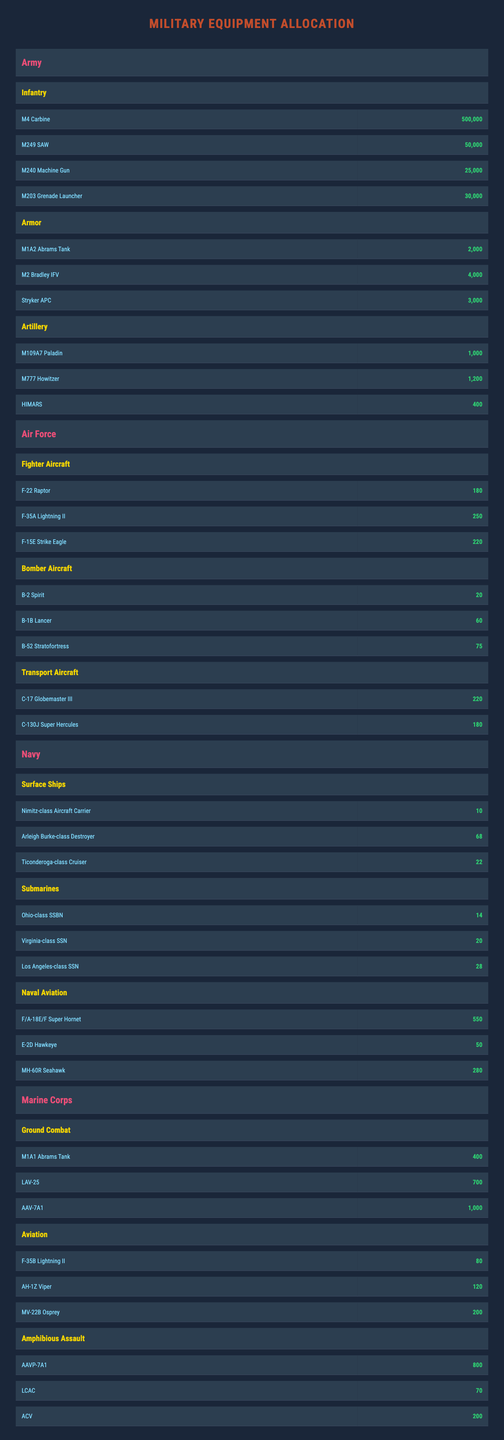What is the total number of M4 Carbines allocated to the Army? The value for M4 Carbine under the Army's Infantry division is 500,000, so the total allocated is simply that value.
Answer: 500,000 Which branch has the highest number of transport aircraft? Under the Air Force, the transport aircraft total up to C-17 (220) and C-130J (180), giving a total of 400. No other branch has transport aircraft listed in the table.
Answer: Air Force How many more F-35A Lightning IIs does the Air Force have compared to the Marine Corps' F-35B Lightning IIs? The Air Force has 250 F-35A Lightning IIs, while the Marine Corps has 80 F-35B Lightning IIs. To find the difference, we subtract 80 from 250, resulting in 170 more.
Answer: 170 What is the combined number of naval surface ships listed? The Navy has 10 Nimitz-class Aircraft Carriers, 68 Arleigh Burke-class Destroyers, and 22 Ticonderoga-class Cruisers. Adding these gives 10 + 68 + 22 = 100 surface ships in total.
Answer: 100 Which branch of the military has the least amount of equipment overall? To answer this, one must sum the total equipment counts of each branch. The Army has 577,000, the Air Force has 425, the Navy has 110, and the Marine Corps has 2,060. The Navy has 110, making it the branch with the least amount of equipment based on total counts.
Answer: Navy Is the number of M1A2 Abrams Tanks greater than that of M1A1 Abrams Tanks? The Army has 2,000 M1A2 Abrams Tanks, and the Marine Corps has 400 M1A1 Abrams Tanks. Since 2,000 is greater than 400, the statement is true.
Answer: Yes What is the average number of artillery pieces across the Army's Artillery division? The Army has three types of artillery: M109A7 Paladin (1,000), M777 Howitzer (1,200), and HIMARS (400). The total is 1,000 + 1,200 + 400 = 2,600. Dividing by 3 shows the average is 2,600 / 3 ≈ 866.67.
Answer: 867 How many aircraft does the Navy have in its Naval Aviation division? The Navy has a total of F/A-18E/F Super Hornets (550), E-2D Hawkeyes (50), and MH-60R Seahawks (280). Adding these together gives 550 + 50 + 280 = 880 aircraft.
Answer: 880 Which equipment has the largest quantity allocated to the Army? The equipment listed, with their respective quantities, include M4 Carbine (500,000), M249 SAW (50,000), M240 Machine Gun (25,000), and M203 Grenade Launcher (30,000). The M4 Carbine has the highest quantity of 500,000.
Answer: M4 Carbine Is the total number of tanks in the Army greater than the total number in the Marine Corps? The Army has 2,000 M1A2 Abrams Tanks and 4,000 M2 Bradley IFVs, totaling 6,000 tanks. The Marine Corps has 400 M1A1 Abrams Tanks. Comparing 6,000 to 400 clearly shows the Army has more.
Answer: Yes 